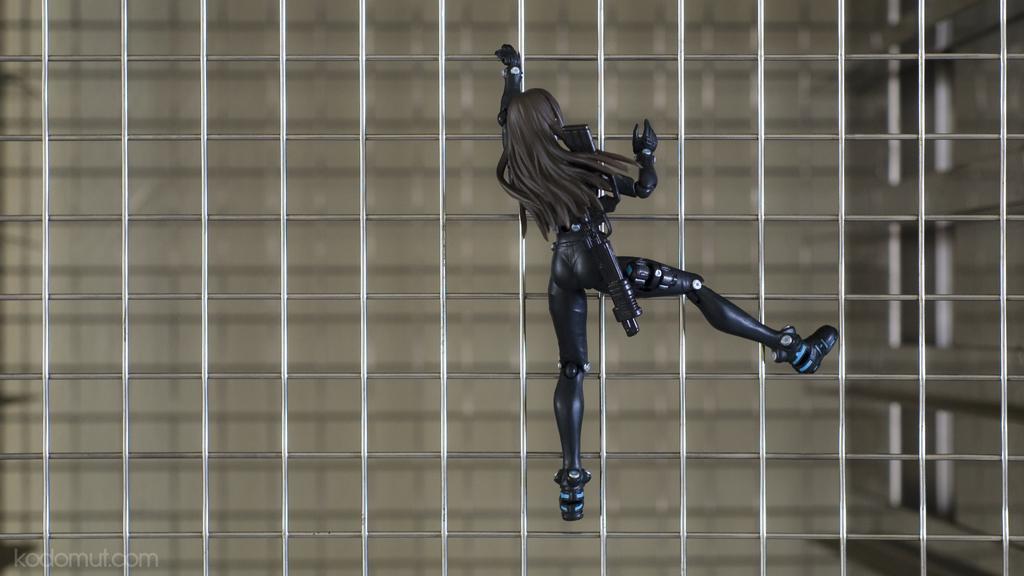Can you describe this image briefly? At the center of the image there is a toy of a woman attached to the mesh. 